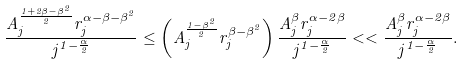Convert formula to latex. <formula><loc_0><loc_0><loc_500><loc_500>\frac { A _ { j } ^ { \frac { 1 + 2 \beta - \beta ^ { 2 } } { 2 } } r _ { j } ^ { \alpha - \beta - \beta ^ { 2 } } } { j ^ { 1 - \frac { \alpha } { 2 } } } \leq \left ( A _ { j } ^ { \frac { 1 - \beta ^ { 2 } } { 2 } } r _ { j } ^ { \beta - \beta ^ { 2 } } \right ) \frac { A _ { j } ^ { \beta } r _ { j } ^ { \alpha - 2 \beta } } { j ^ { 1 - \frac { \alpha } { 2 } } } < < \frac { A _ { j } ^ { \beta } r _ { j } ^ { \alpha - 2 \beta } } { j ^ { 1 - \frac { \alpha } { 2 } } } .</formula> 